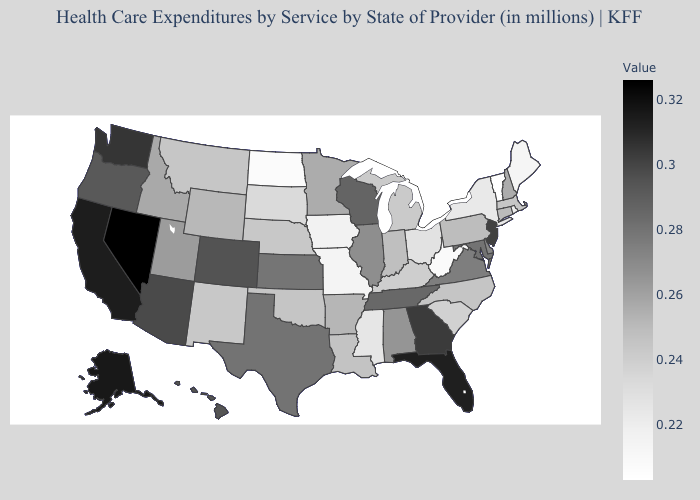Does Delaware have the highest value in the South?
Concise answer only. No. Is the legend a continuous bar?
Short answer required. Yes. Does Virginia have a higher value than Minnesota?
Short answer required. Yes. Which states have the highest value in the USA?
Answer briefly. Nevada. Which states have the highest value in the USA?
Be succinct. Nevada. Is the legend a continuous bar?
Be succinct. Yes. Among the states that border West Virginia , does Virginia have the lowest value?
Answer briefly. No. 